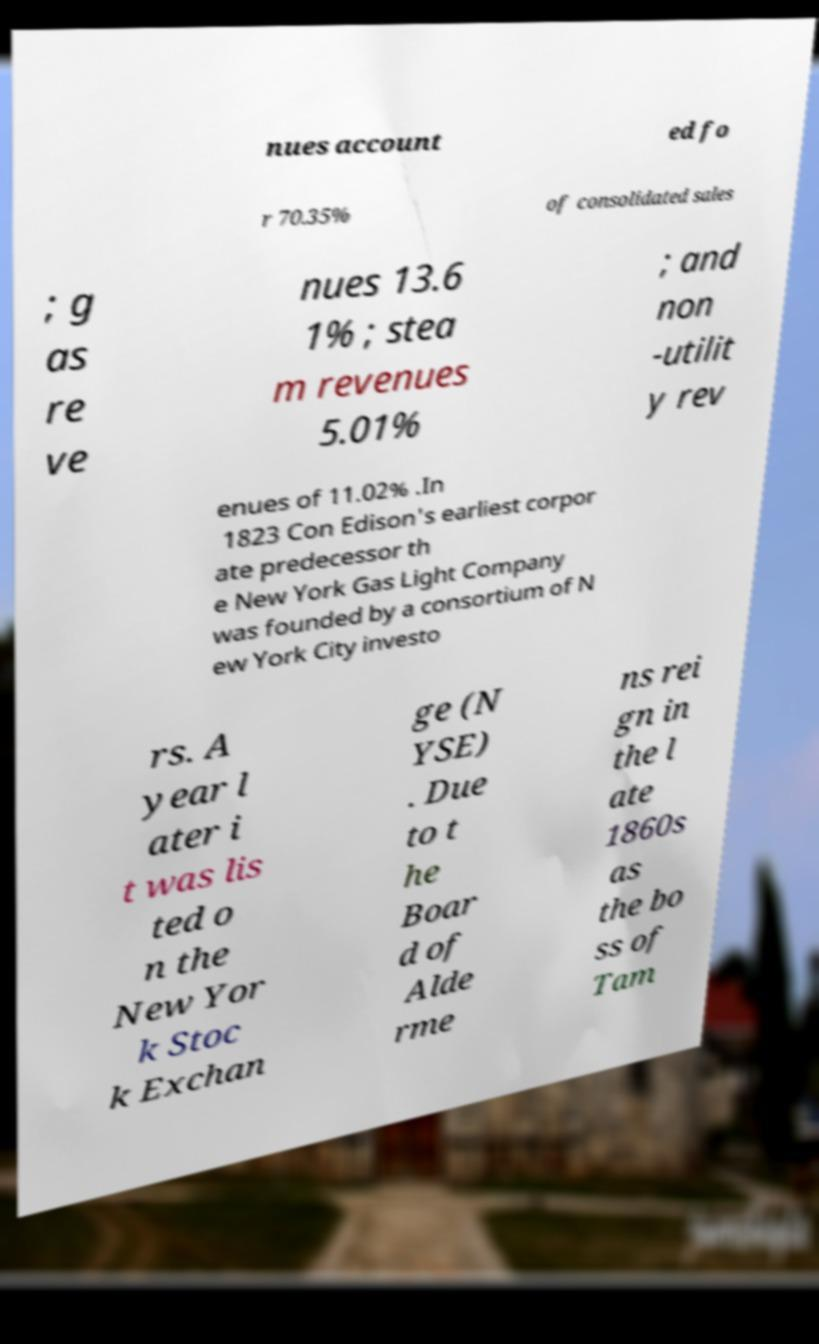Could you extract and type out the text from this image? nues account ed fo r 70.35% of consolidated sales ; g as re ve nues 13.6 1% ; stea m revenues 5.01% ; and non -utilit y rev enues of 11.02% .In 1823 Con Edison's earliest corpor ate predecessor th e New York Gas Light Company was founded by a consortium of N ew York City investo rs. A year l ater i t was lis ted o n the New Yor k Stoc k Exchan ge (N YSE) . Due to t he Boar d of Alde rme ns rei gn in the l ate 1860s as the bo ss of Tam 